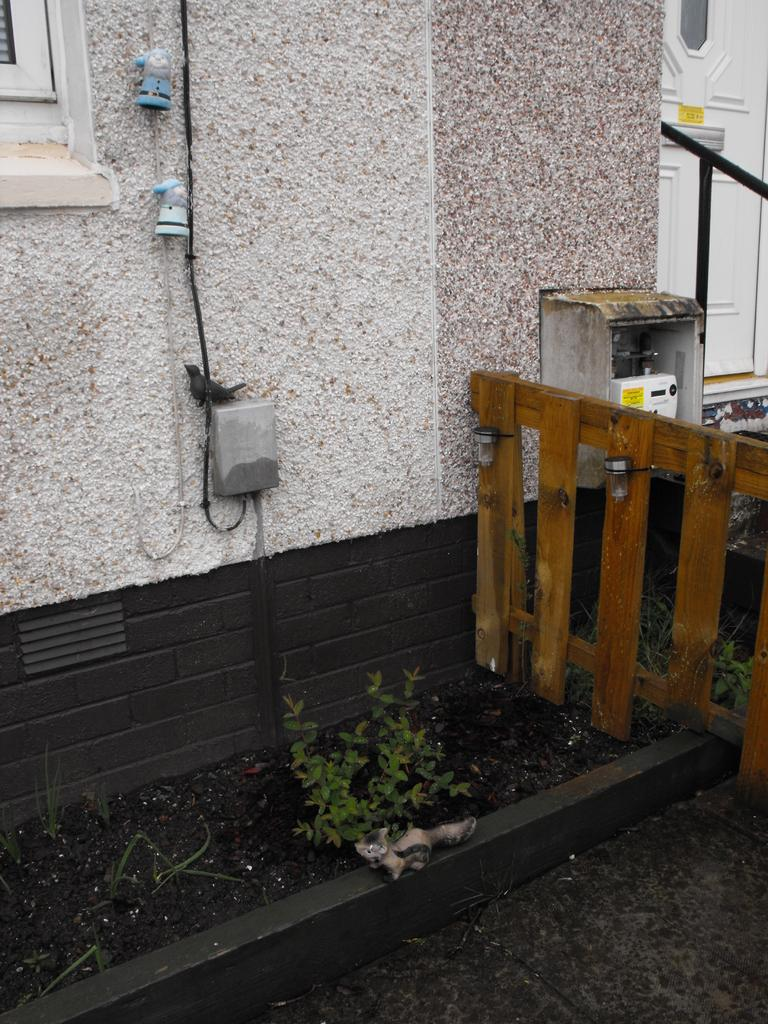What is located in front of the wall in the image? There is a plant in front of the wall. What type of fence can be seen on the right side of the image? There is a wooden fence on the right side of the image. What is attached to the wall in the image? There is a box on the wall. What type of thought is being expressed by the committee in the image? There is no committee or thought expressed in the image; it features a plant, a wooden fence, and a box on the wall. How does the plant twist around the wooden fence in the image? The plant does not twist around the wooden fence in the image; it is simply located in front of the wall. 